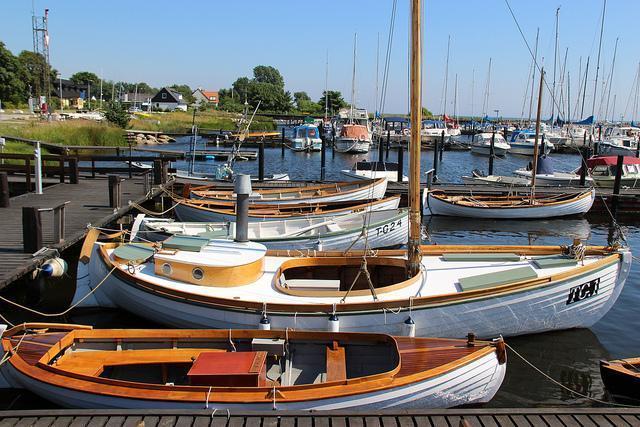How many boats are in the picture?
Give a very brief answer. 6. How many baby horses are in the field?
Give a very brief answer. 0. 